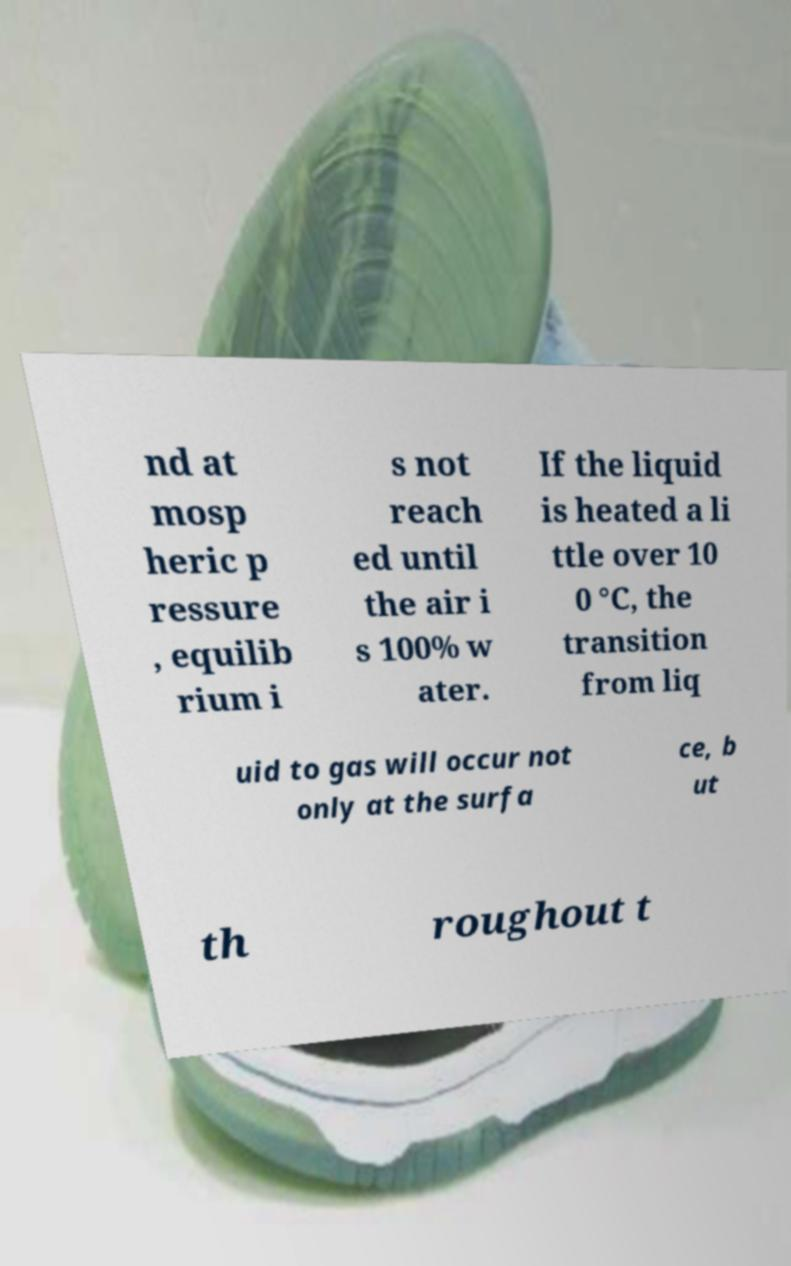What messages or text are displayed in this image? I need them in a readable, typed format. nd at mosp heric p ressure , equilib rium i s not reach ed until the air i s 100% w ater. If the liquid is heated a li ttle over 10 0 °C, the transition from liq uid to gas will occur not only at the surfa ce, b ut th roughout t 